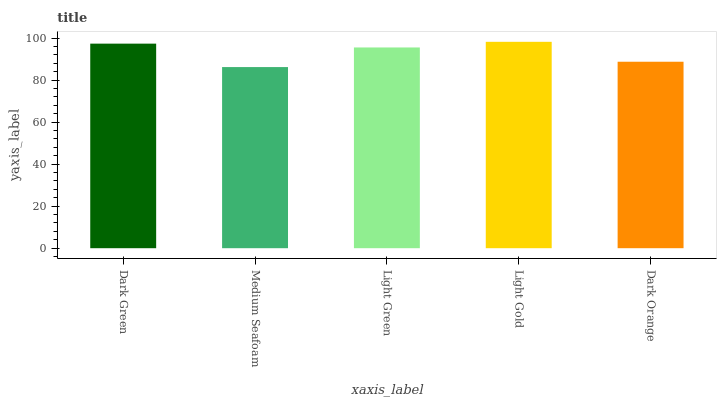Is Light Green the minimum?
Answer yes or no. No. Is Light Green the maximum?
Answer yes or no. No. Is Light Green greater than Medium Seafoam?
Answer yes or no. Yes. Is Medium Seafoam less than Light Green?
Answer yes or no. Yes. Is Medium Seafoam greater than Light Green?
Answer yes or no. No. Is Light Green less than Medium Seafoam?
Answer yes or no. No. Is Light Green the high median?
Answer yes or no. Yes. Is Light Green the low median?
Answer yes or no. Yes. Is Dark Orange the high median?
Answer yes or no. No. Is Dark Green the low median?
Answer yes or no. No. 